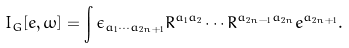Convert formula to latex. <formula><loc_0><loc_0><loc_500><loc_500>I _ { G } [ e , \omega ] = \int \epsilon _ { a _ { 1 } \cdots a _ { 2 n + 1 } } R ^ { a _ { 1 } a _ { 2 } } \cdots R ^ { a _ { 2 n - 1 } a _ { 2 n } } e ^ { a _ { 2 n + 1 } } .</formula> 